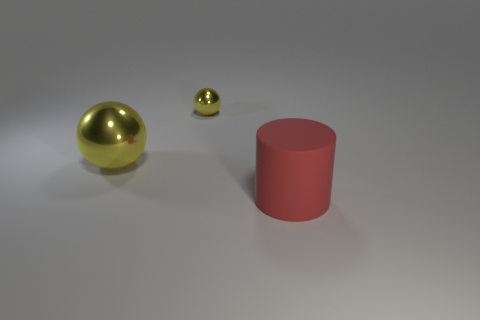What materials appear to be used for the objects in this image? The objects in this image seem to be made of different materials. The two spherical objects look metallic, likely representing gold, whereas the cylindrical object seems to be made of a matte material, possibly plastic or painted metal. 